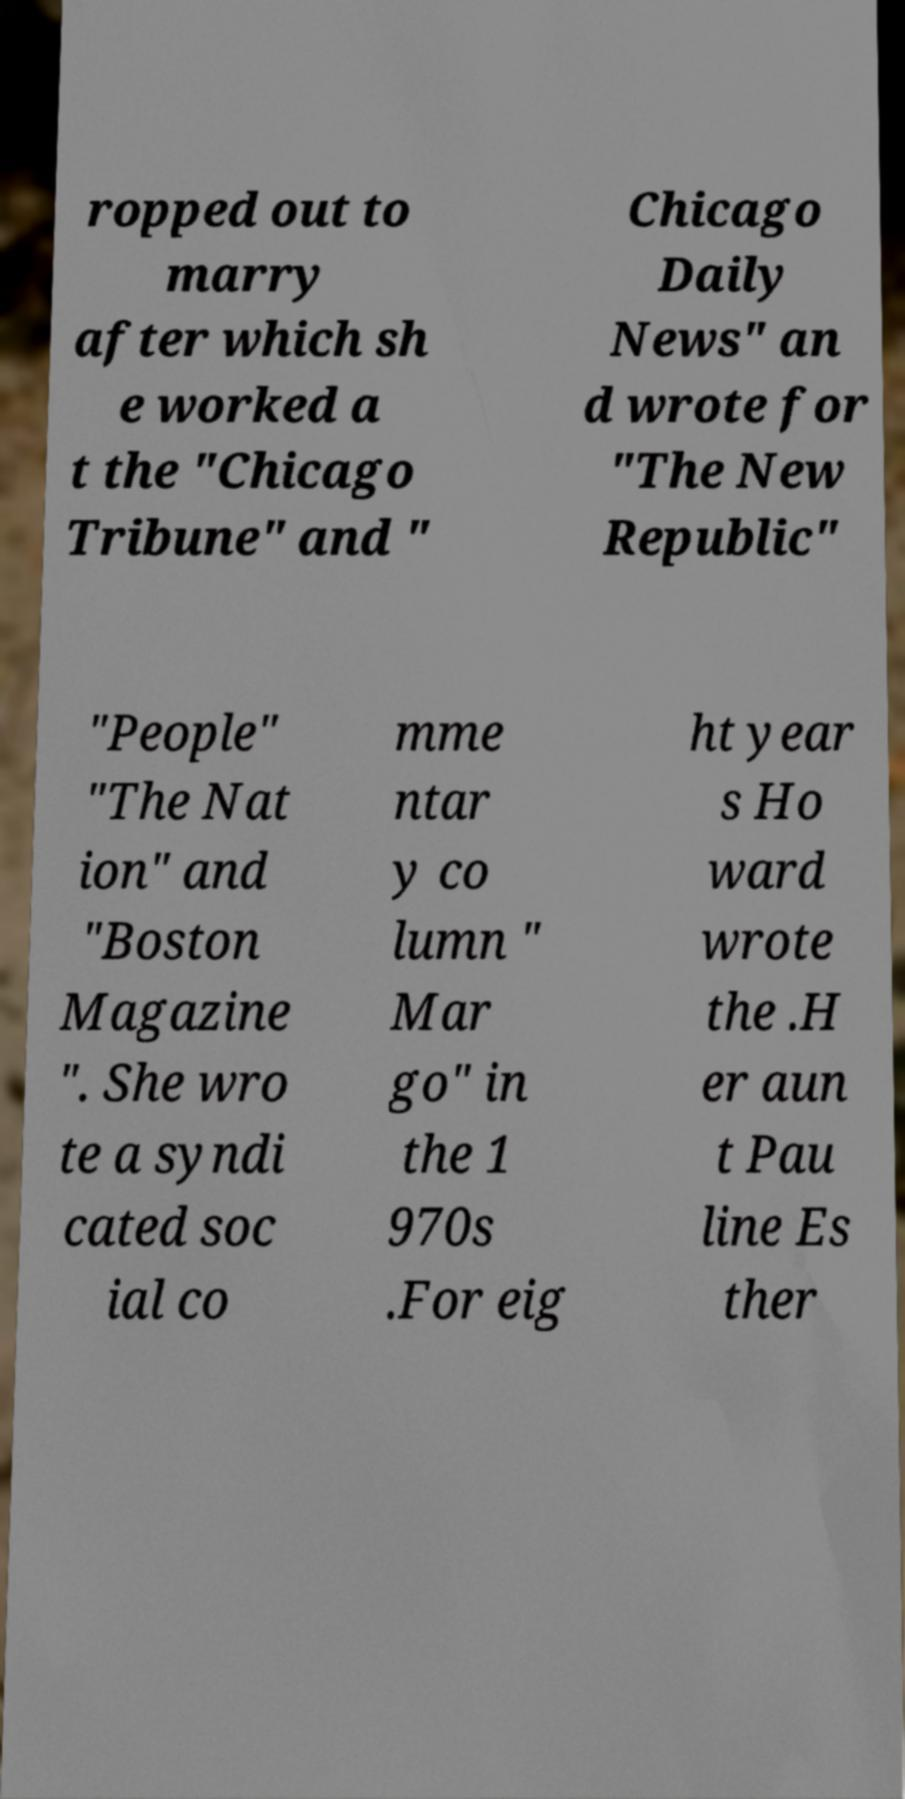Can you accurately transcribe the text from the provided image for me? ropped out to marry after which sh e worked a t the "Chicago Tribune" and " Chicago Daily News" an d wrote for "The New Republic" "People" "The Nat ion" and "Boston Magazine ". She wro te a syndi cated soc ial co mme ntar y co lumn " Mar go" in the 1 970s .For eig ht year s Ho ward wrote the .H er aun t Pau line Es ther 